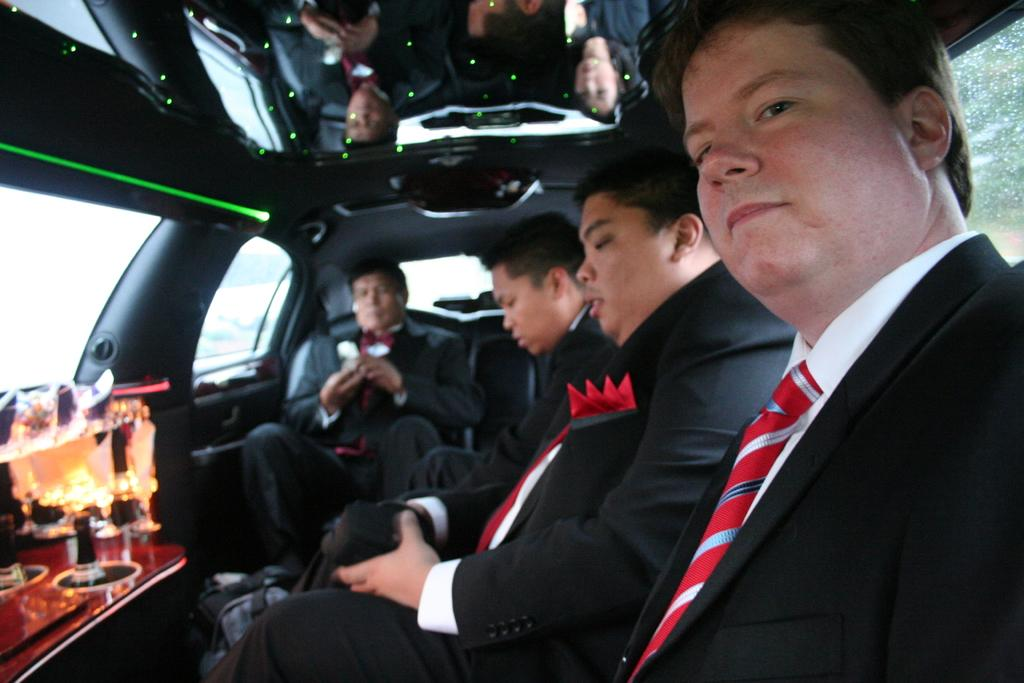What is happening in the image? There is a group of people in the image, and they are seated in a car. Can you describe any objects visible in the image? There are at least two glasses visible in the image. What type of pollution can be seen coming from the cannon in the image? There is no cannon present in the image, so it is not possible to determine what type of pollution might be coming from it. 